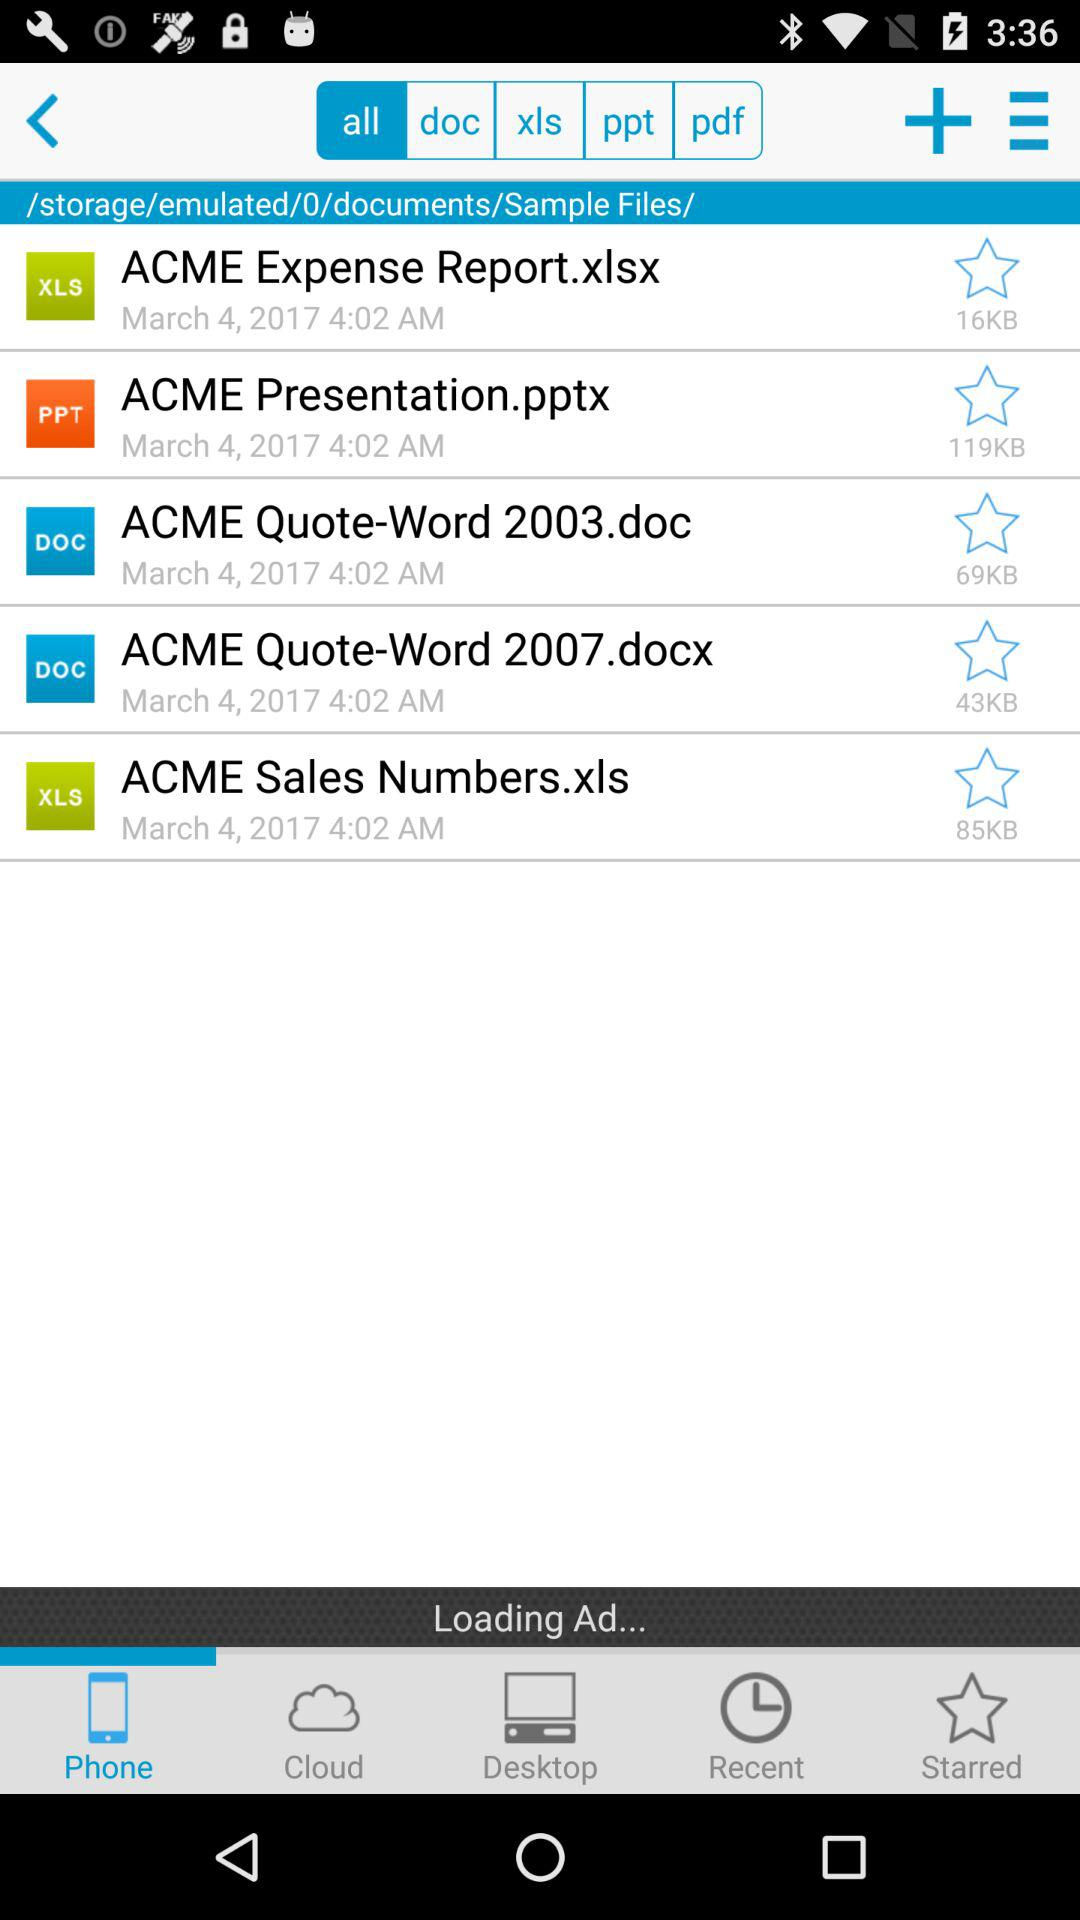What is the mentioned time? The mentioned time is 4:02 AM. 